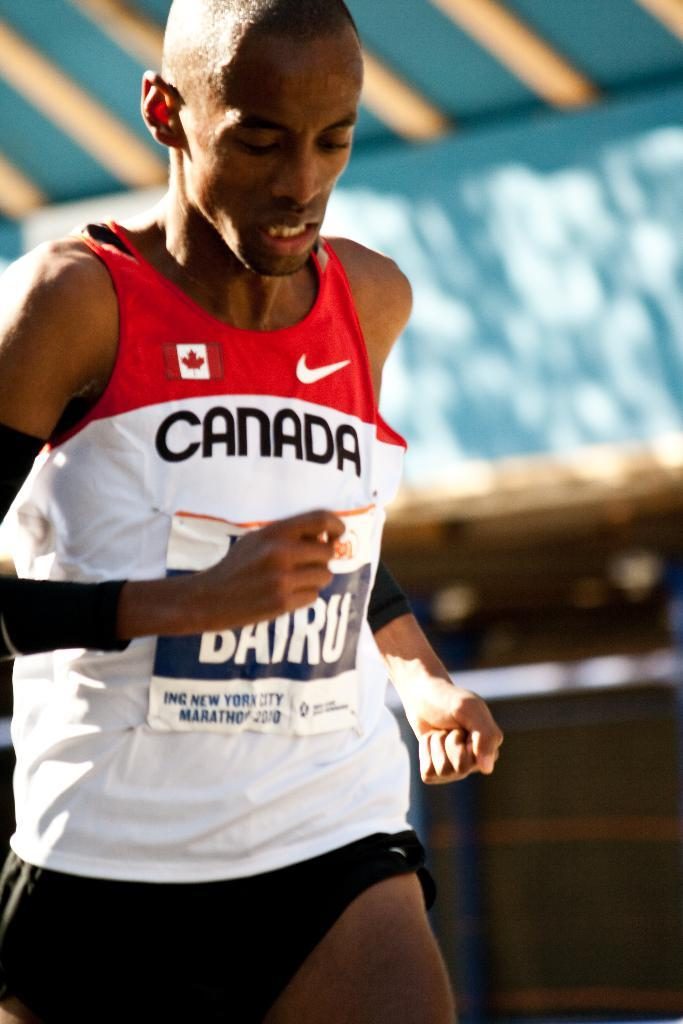Provide a one-sentence caption for the provided image. A black man running wearing a canada shirt while doing so. 